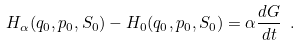<formula> <loc_0><loc_0><loc_500><loc_500>H _ { \alpha } ( q _ { 0 } , p _ { 0 } , S _ { 0 } ) - H _ { 0 } ( q _ { 0 } , p _ { 0 } , S _ { 0 } ) = \alpha \frac { d G } { d t } \ .</formula> 